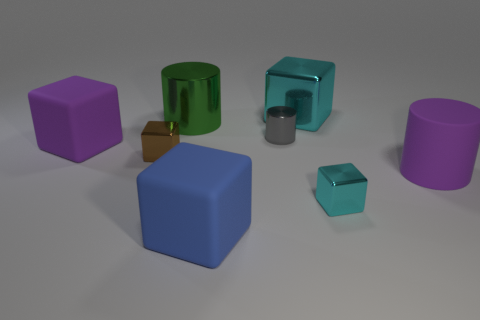There is a big object that is in front of the purple cube and behind the small cyan metallic block; what is its material?
Give a very brief answer. Rubber. What material is the other cyan object that is the same shape as the tiny cyan object?
Ensure brevity in your answer.  Metal. There is a cyan metal block on the left side of the cyan shiny cube in front of the purple matte cylinder; how many big cyan metal things are behind it?
Your response must be concise. 0. Is there any other thing that has the same color as the small cylinder?
Provide a succinct answer. No. How many big matte objects are right of the blue cube and behind the purple cylinder?
Your answer should be compact. 0. There is a cyan metallic block that is in front of the gray metal object; is it the same size as the purple rubber thing in front of the purple cube?
Give a very brief answer. No. What number of objects are cyan things behind the green metallic cylinder or tiny purple rubber cubes?
Provide a short and direct response. 1. There is a purple thing that is to the right of the small brown metallic thing; what material is it?
Ensure brevity in your answer.  Rubber. What material is the gray object?
Provide a short and direct response. Metal. There is a purple object that is right of the rubber object in front of the matte thing that is right of the big blue rubber thing; what is its material?
Keep it short and to the point. Rubber. 